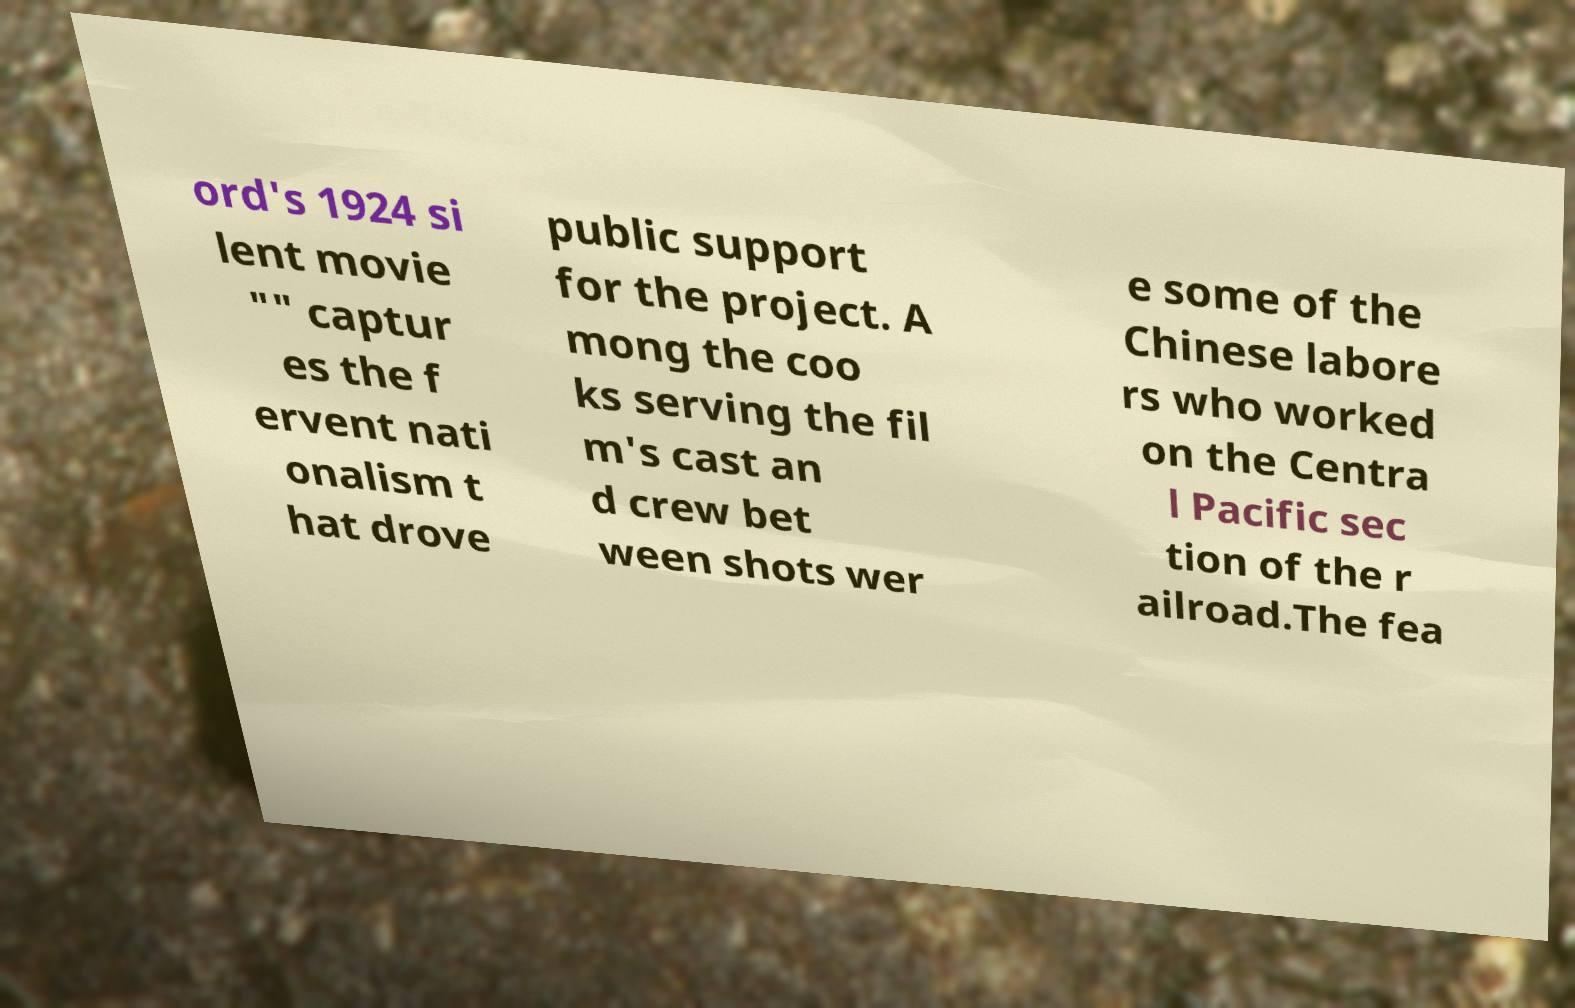Please read and relay the text visible in this image. What does it say? ord's 1924 si lent movie "" captur es the f ervent nati onalism t hat drove public support for the project. A mong the coo ks serving the fil m's cast an d crew bet ween shots wer e some of the Chinese labore rs who worked on the Centra l Pacific sec tion of the r ailroad.The fea 